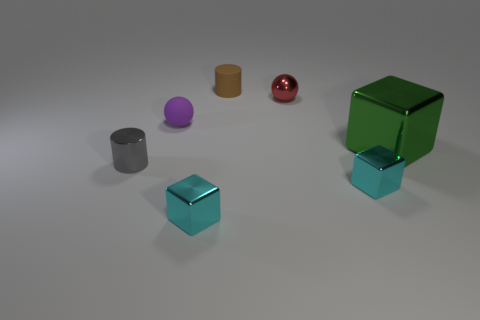Add 3 small purple blocks. How many objects exist? 10 Subtract all cylinders. How many objects are left? 5 Subtract all small red spheres. Subtract all small red blocks. How many objects are left? 6 Add 5 brown cylinders. How many brown cylinders are left? 6 Add 5 tiny cyan blocks. How many tiny cyan blocks exist? 7 Subtract 0 brown spheres. How many objects are left? 7 